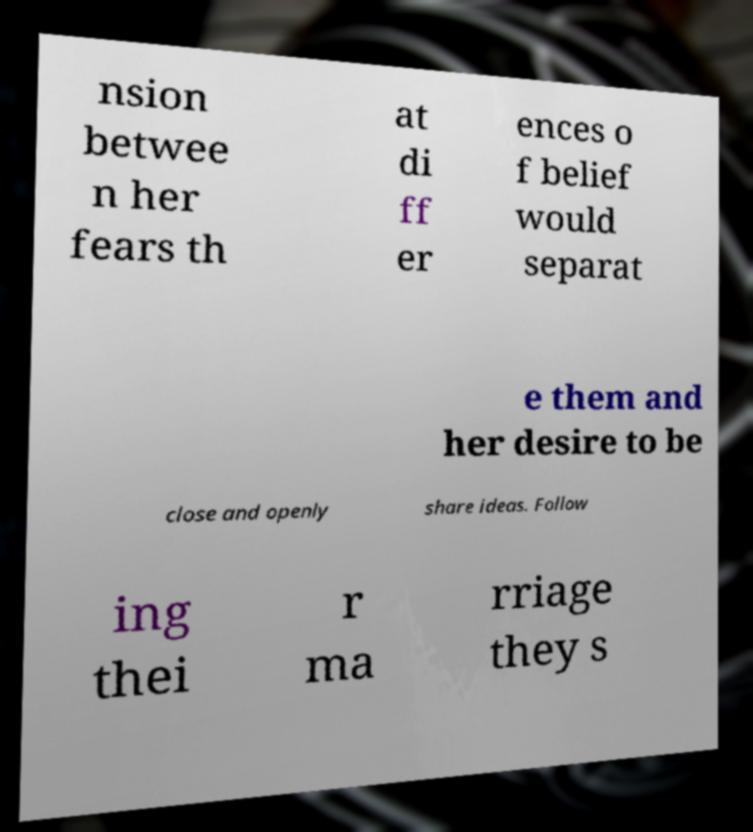Could you extract and type out the text from this image? nsion betwee n her fears th at di ff er ences o f belief would separat e them and her desire to be close and openly share ideas. Follow ing thei r ma rriage they s 